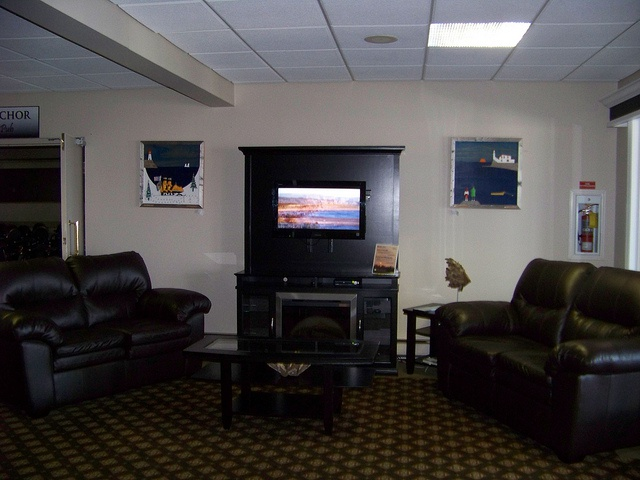Describe the objects in this image and their specific colors. I can see couch in black, gray, and darkgreen tones, couch in black, gray, and darkgreen tones, tv in black, lavender, and darkgray tones, and remote in black, gray, and darkgreen tones in this image. 